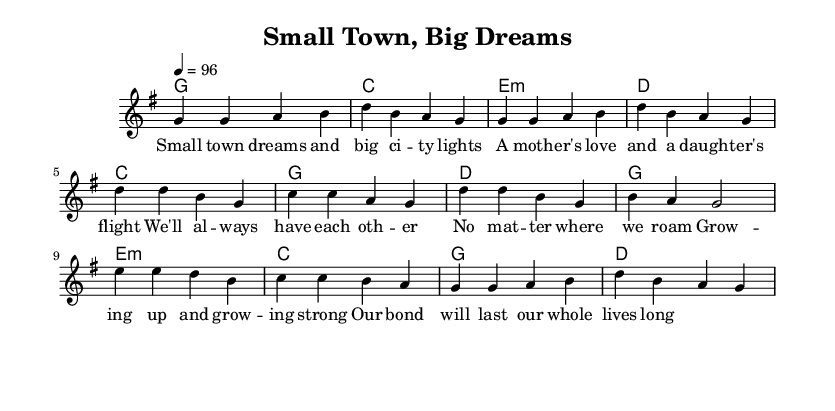What is the key signature of this music? The key signature is G major, indicated by one sharp (F#) in the music. You can tell because the key signature is often shown at the beginning of the staff, and no other alterations are present.
Answer: G major What is the time signature of the piece? The time signature is 4/4, which means there are four beats in each measure, and the quarter note gets one beat. This information is typically located near the beginning of the score, directly after the key signature.
Answer: 4/4 What is the tempo marking for this piece? The tempo marking is quarter note equals 96, indicating that the quarter note should be played at 96 beats per minute. This is stated clearly at the beginning of the score.
Answer: 96 How many measures are there in the verse? There are four measures in the verse section, as each musical section can be counted by examining the number of vertical bar lines that separate the measures within the music staff.
Answer: 4 How does the chorus differ in progression compared to the verse? The chorus uses a different chord progression, specifically moving from C to G to D to G, highlighting a musical contrast. The chord changes in the chorus can be identified by examining the chord names above the melody in each respective section.
Answer: C, G, D, G What thematic elements are present in the lyrics? The lyrics focus on the bond between a mother and daughter, emphasizing themes of love, growth, and support. This can be inferred from analyzing the words of the lyrics associated with each musical part (verse, chorus, bridge).
Answer: Mother-daughter bond What instrument is primarily used in this arrangement? The primary instrument is indicated by the staff designation, which is a voice for melody. In the context of country rock, this implies an acoustic guitar or vocal arrangement is likely featured.
Answer: Voice 